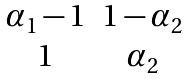Convert formula to latex. <formula><loc_0><loc_0><loc_500><loc_500>\begin{matrix} \alpha _ { 1 } - 1 & 1 - \alpha _ { 2 } \\ 1 & \alpha _ { 2 } \\ \end{matrix}</formula> 